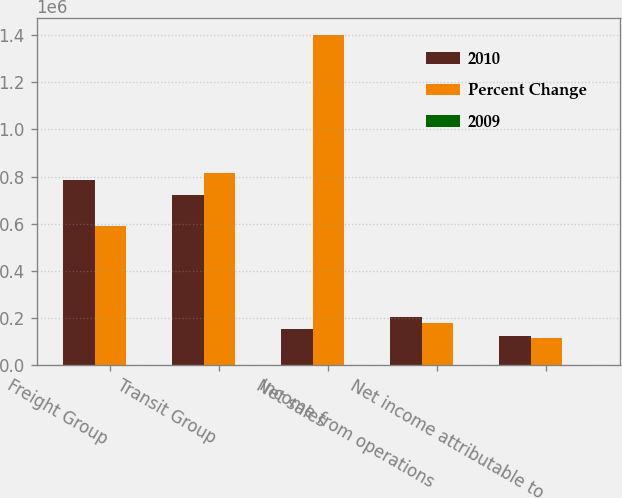Convert chart. <chart><loc_0><loc_0><loc_500><loc_500><stacked_bar_chart><ecel><fcel>Freight Group<fcel>Transit Group<fcel>Net sales<fcel>Income from operations<fcel>Net income attributable to<nl><fcel>2010<fcel>784504<fcel>722508<fcel>151566<fcel>202810<fcel>123099<nl><fcel>Percent Change<fcel>588399<fcel>813217<fcel>1.40162e+06<fcel>180032<fcel>115055<nl><fcel>2009<fcel>33.3<fcel>11.2<fcel>7.5<fcel>12.7<fcel>7<nl></chart> 